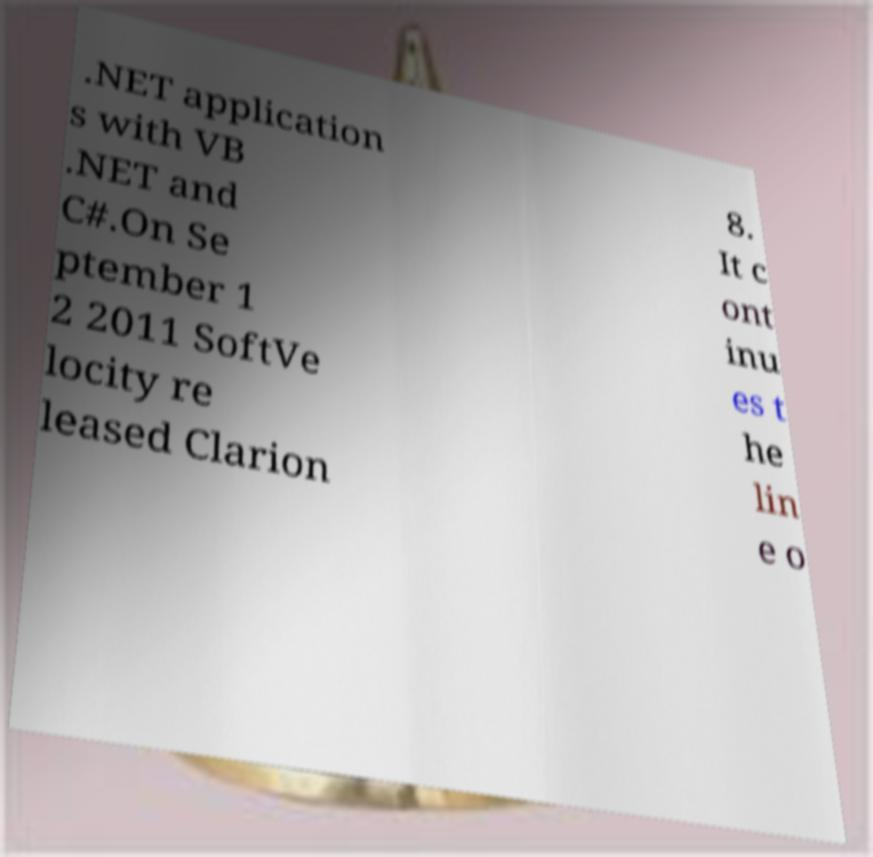Could you assist in decoding the text presented in this image and type it out clearly? .NET application s with VB .NET and C#.On Se ptember 1 2 2011 SoftVe locity re leased Clarion 8. It c ont inu es t he lin e o 